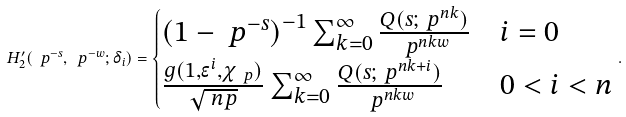<formula> <loc_0><loc_0><loc_500><loc_500>H _ { 2 } ^ { \prime } ( \ p ^ { - s } , \ p ^ { - w } ; \delta _ { i } ) = \begin{cases} \left ( 1 - \ p ^ { - s } \right ) ^ { - 1 } \sum _ { k = 0 } ^ { \infty } \frac { Q ( s ; \ p ^ { n k } ) } { \ p ^ { n k w } } & i = 0 \\ \frac { g ( 1 , \epsilon ^ { i } , \chi _ { \ p } ) } { \sqrt { \ n p } } \sum _ { k = 0 } ^ { \infty } \frac { Q ( s ; \ p ^ { n k + i } ) } { \ p ^ { n k w } } & 0 < i < n \\ \end{cases} .</formula> 